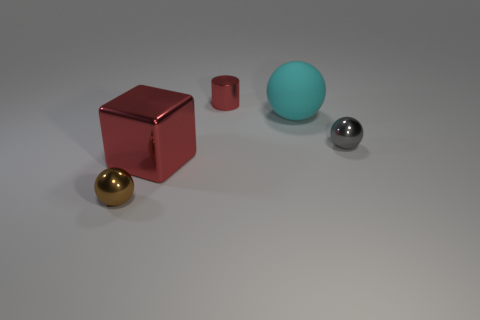Add 3 spheres. How many objects exist? 8 Subtract all gray balls. How many balls are left? 2 Subtract all cyan matte balls. How many balls are left? 2 Subtract 1 brown spheres. How many objects are left? 4 Subtract all cubes. How many objects are left? 4 Subtract all purple blocks. Subtract all red cylinders. How many blocks are left? 1 Subtract all purple cubes. How many green balls are left? 0 Subtract all large blue rubber spheres. Subtract all large things. How many objects are left? 3 Add 1 tiny brown metallic spheres. How many tiny brown metallic spheres are left? 2 Add 1 small metal cylinders. How many small metal cylinders exist? 2 